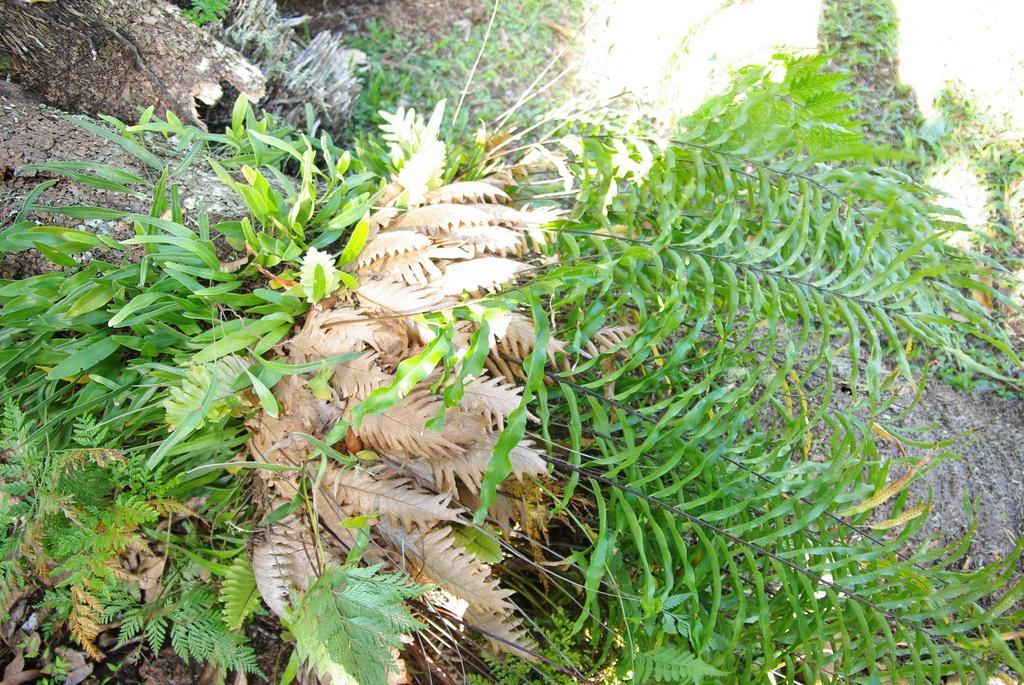Please provide a concise description of this image. In this image I can see the trunks and plants on the ground. 